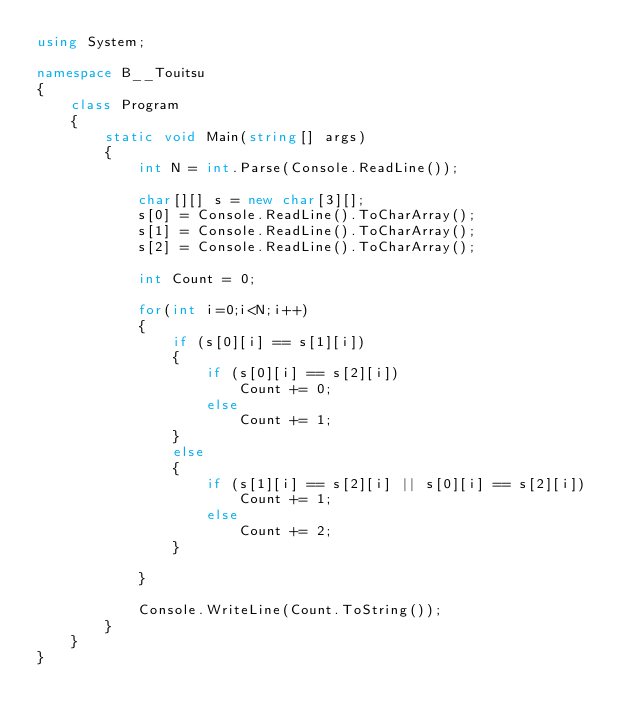Convert code to text. <code><loc_0><loc_0><loc_500><loc_500><_C#_>using System;

namespace B__Touitsu
{
    class Program
    {
        static void Main(string[] args)
        {
            int N = int.Parse(Console.ReadLine());

            char[][] s = new char[3][];
            s[0] = Console.ReadLine().ToCharArray();
            s[1] = Console.ReadLine().ToCharArray();
            s[2] = Console.ReadLine().ToCharArray();

            int Count = 0;

            for(int i=0;i<N;i++)
            {
                if (s[0][i] == s[1][i])
                {
                    if (s[0][i] == s[2][i])
                        Count += 0;
                    else
                        Count += 1;
                } 
                else
                {
                    if (s[1][i] == s[2][i] || s[0][i] == s[2][i])
                        Count += 1;
                    else
                        Count += 2;
                }

            }

            Console.WriteLine(Count.ToString());
        }
    }
}
</code> 